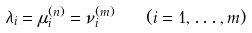Convert formula to latex. <formula><loc_0><loc_0><loc_500><loc_500>\lambda _ { i } = \mu ^ { ( n ) } _ { i } = \nu ^ { ( m ) } _ { i } \quad ( i = 1 , \dots , m )</formula> 